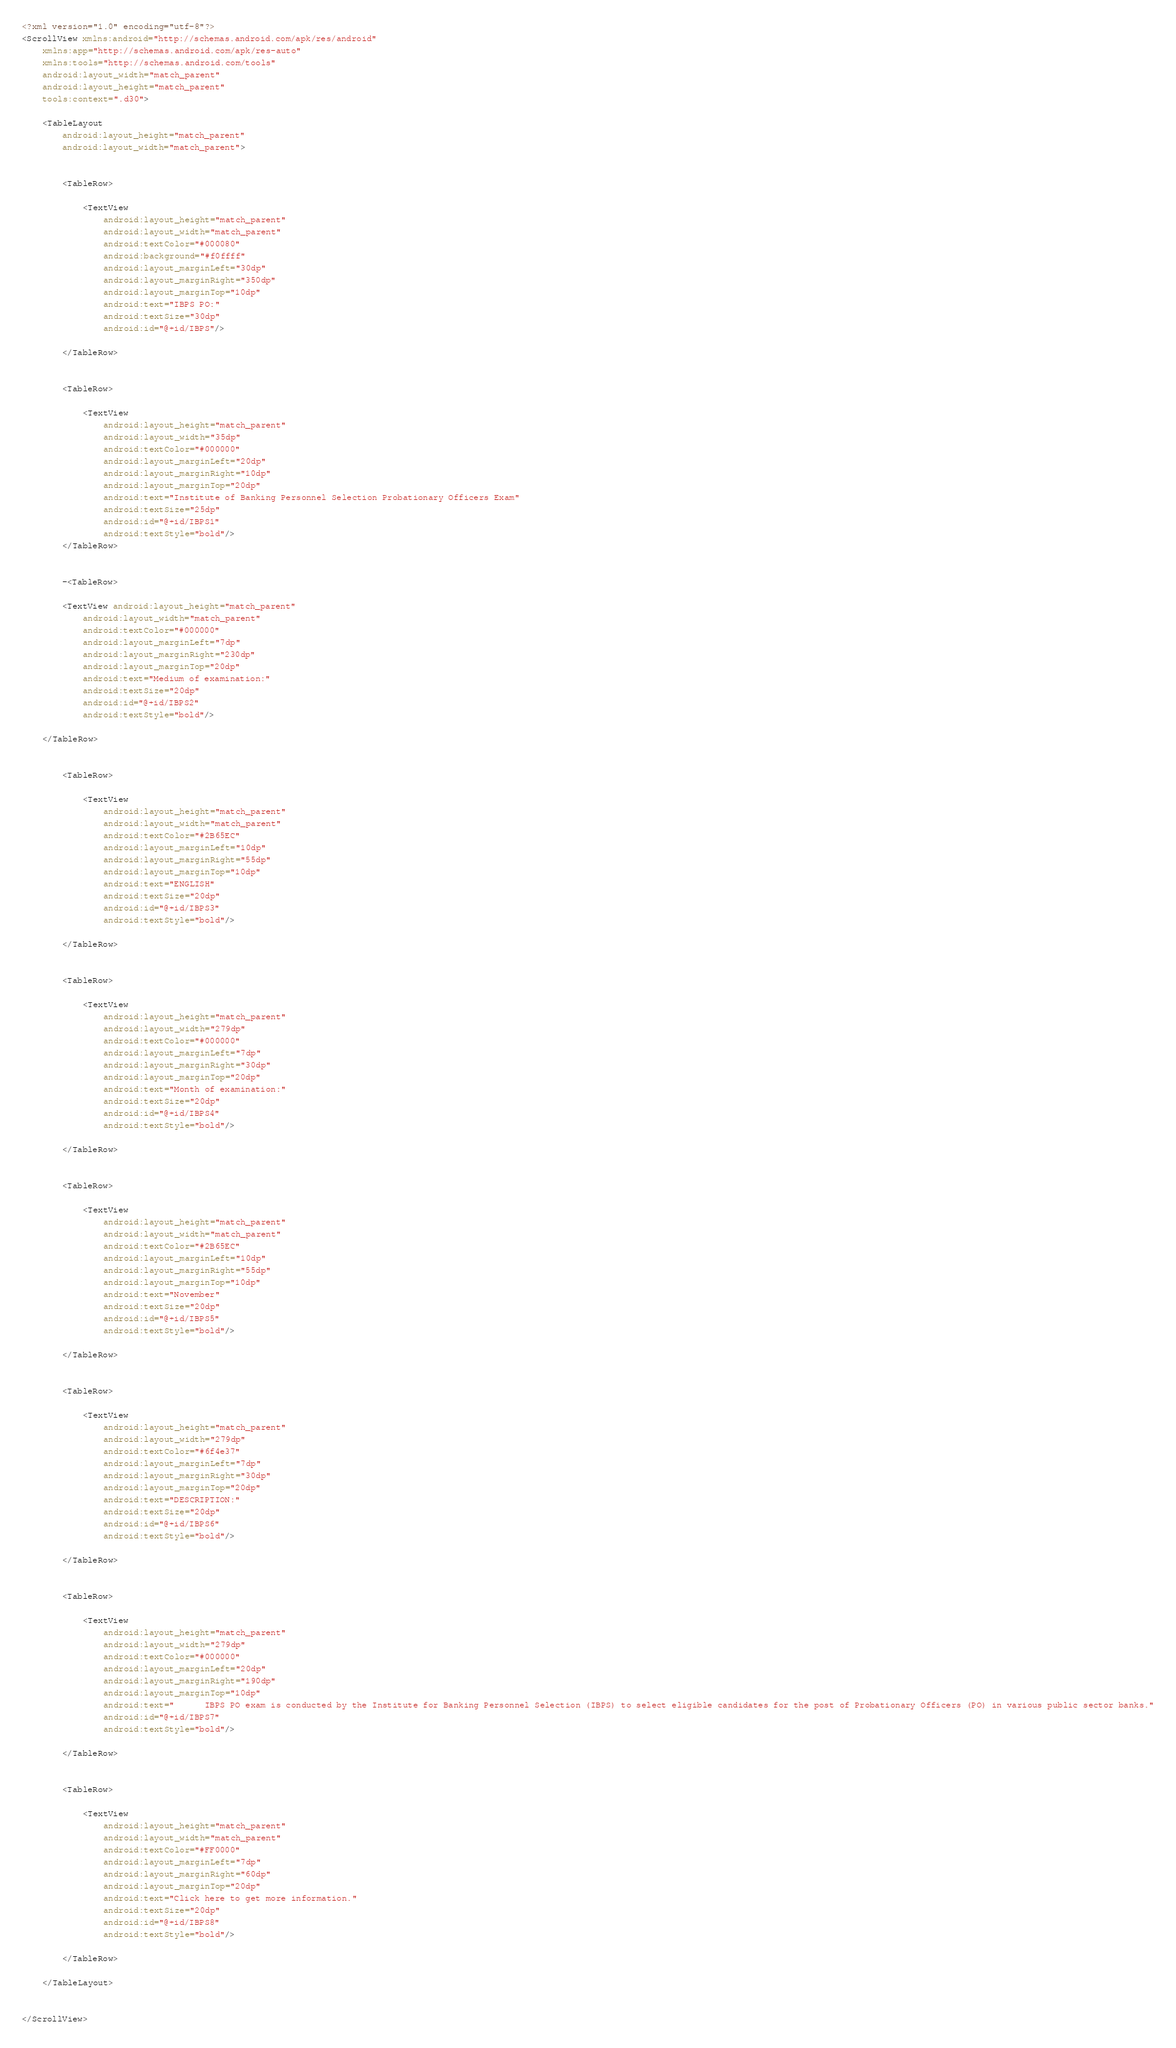Convert code to text. <code><loc_0><loc_0><loc_500><loc_500><_XML_><?xml version="1.0" encoding="utf-8"?>
<ScrollView xmlns:android="http://schemas.android.com/apk/res/android"
    xmlns:app="http://schemas.android.com/apk/res-auto"
    xmlns:tools="http://schemas.android.com/tools"
    android:layout_width="match_parent"
    android:layout_height="match_parent"
    tools:context=".d30">

    <TableLayout
        android:layout_height="match_parent"
        android:layout_width="match_parent">


        <TableRow>

            <TextView
                android:layout_height="match_parent"
                android:layout_width="match_parent"
                android:textColor="#000080"
                android:background="#f0ffff"
                android:layout_marginLeft="30dp"
                android:layout_marginRight="350dp"
                android:layout_marginTop="10dp"
                android:text="IBPS PO:"
                android:textSize="30dp"
                android:id="@+id/IBPS"/>

        </TableRow>


        <TableRow>

            <TextView
                android:layout_height="match_parent"
                android:layout_width="35dp"
                android:textColor="#000000"
                android:layout_marginLeft="20dp"
                android:layout_marginRight="10dp"
                android:layout_marginTop="20dp"
                android:text="Institute of Banking Personnel Selection Probationary Officers Exam"
                android:textSize="25dp"
                android:id="@+id/IBPS1"
                android:textStyle="bold"/>
        </TableRow>


        -<TableRow>

        <TextView android:layout_height="match_parent"
            android:layout_width="match_parent"
            android:textColor="#000000"
            android:layout_marginLeft="7dp"
            android:layout_marginRight="230dp"
            android:layout_marginTop="20dp"
            android:text="Medium of examination:"
            android:textSize="20dp"
            android:id="@+id/IBPS2"
            android:textStyle="bold"/>

    </TableRow>


        <TableRow>

            <TextView
                android:layout_height="match_parent"
                android:layout_width="match_parent"
                android:textColor="#2B65EC"
                android:layout_marginLeft="10dp"
                android:layout_marginRight="55dp"
                android:layout_marginTop="10dp"
                android:text="ENGLISH"
                android:textSize="20dp"
                android:id="@+id/IBPS3"
                android:textStyle="bold"/>

        </TableRow>


        <TableRow>

            <TextView
                android:layout_height="match_parent"
                android:layout_width="279dp"
                android:textColor="#000000"
                android:layout_marginLeft="7dp"
                android:layout_marginRight="30dp"
                android:layout_marginTop="20dp"
                android:text="Month of examination:"
                android:textSize="20dp"
                android:id="@+id/IBPS4"
                android:textStyle="bold"/>

        </TableRow>


        <TableRow>

            <TextView
                android:layout_height="match_parent"
                android:layout_width="match_parent"
                android:textColor="#2B65EC"
                android:layout_marginLeft="10dp"
                android:layout_marginRight="55dp"
                android:layout_marginTop="10dp"
                android:text="November"
                android:textSize="20dp"
                android:id="@+id/IBPS5"
                android:textStyle="bold"/>

        </TableRow>


        <TableRow>

            <TextView
                android:layout_height="match_parent"
                android:layout_width="279dp"
                android:textColor="#6f4e37"
                android:layout_marginLeft="7dp"
                android:layout_marginRight="30dp"
                android:layout_marginTop="20dp"
                android:text="DESCRIPTION:"
                android:textSize="20dp"
                android:id="@+id/IBPS6"
                android:textStyle="bold"/>

        </TableRow>


        <TableRow>

            <TextView
                android:layout_height="match_parent"
                android:layout_width="279dp"
                android:textColor="#000000"
                android:layout_marginLeft="20dp"
                android:layout_marginRight="190dp"
                android:layout_marginTop="10dp"
                android:text="      IBPS PO exam is conducted by the Institute for Banking Personnel Selection (IBPS) to select eligible candidates for the post of Probationary Officers (PO) in various public sector banks."
                android:id="@+id/IBPS7"
                android:textStyle="bold"/>

        </TableRow>


        <TableRow>

            <TextView
                android:layout_height="match_parent"
                android:layout_width="match_parent"
                android:textColor="#FF0000"
                android:layout_marginLeft="7dp"
                android:layout_marginRight="60dp"
                android:layout_marginTop="20dp"
                android:text="Click here to get more information."
                android:textSize="20dp"
                android:id="@+id/IBPS8"
                android:textStyle="bold"/>

        </TableRow>

    </TableLayout>


</ScrollView></code> 